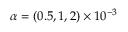<formula> <loc_0><loc_0><loc_500><loc_500>\alpha = ( 0 . 5 , 1 , 2 ) \times 1 0 ^ { - 3 }</formula> 